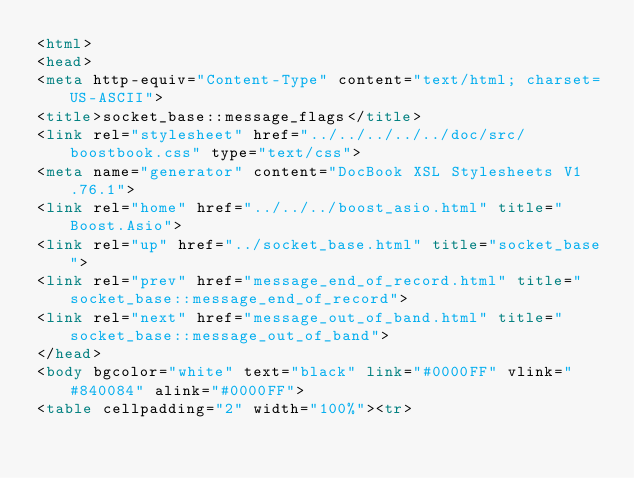Convert code to text. <code><loc_0><loc_0><loc_500><loc_500><_HTML_><html>
<head>
<meta http-equiv="Content-Type" content="text/html; charset=US-ASCII">
<title>socket_base::message_flags</title>
<link rel="stylesheet" href="../../../../../doc/src/boostbook.css" type="text/css">
<meta name="generator" content="DocBook XSL Stylesheets V1.76.1">
<link rel="home" href="../../../boost_asio.html" title="Boost.Asio">
<link rel="up" href="../socket_base.html" title="socket_base">
<link rel="prev" href="message_end_of_record.html" title="socket_base::message_end_of_record">
<link rel="next" href="message_out_of_band.html" title="socket_base::message_out_of_band">
</head>
<body bgcolor="white" text="black" link="#0000FF" vlink="#840084" alink="#0000FF">
<table cellpadding="2" width="100%"><tr></code> 